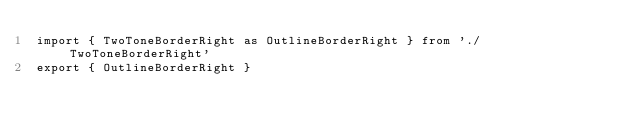Convert code to text. <code><loc_0><loc_0><loc_500><loc_500><_JavaScript_>import { TwoToneBorderRight as OutlineBorderRight } from './TwoToneBorderRight'
export { OutlineBorderRight }
</code> 